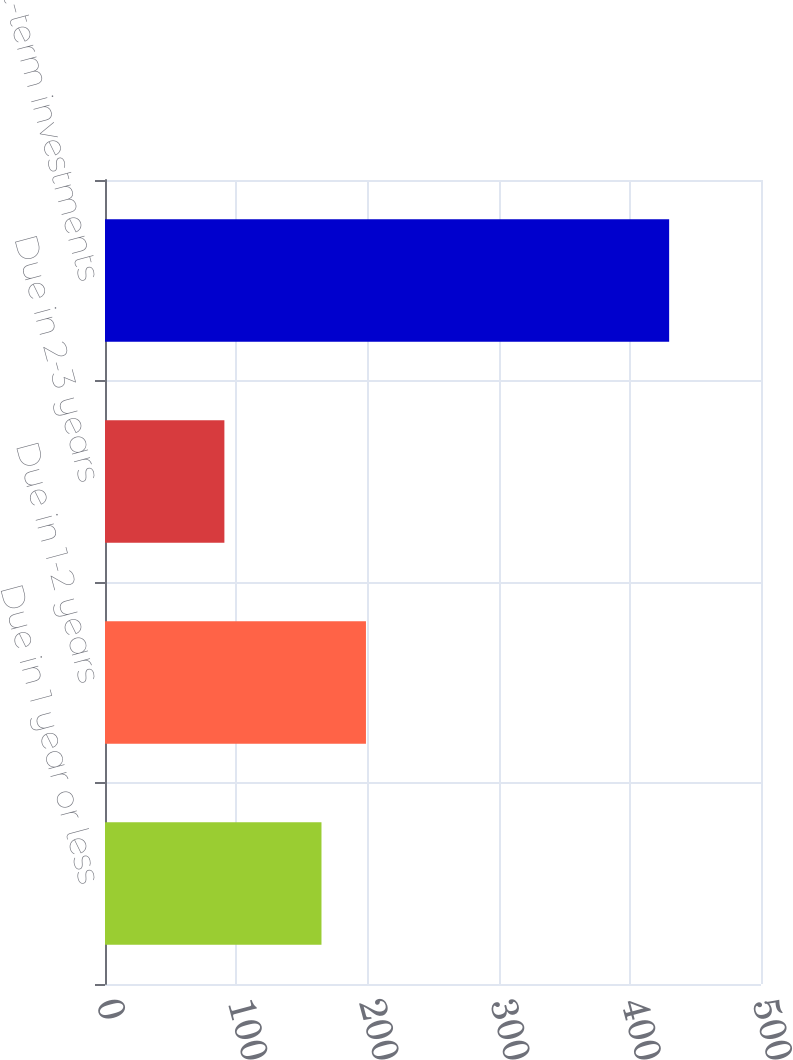<chart> <loc_0><loc_0><loc_500><loc_500><bar_chart><fcel>Due in 1 year or less<fcel>Due in 1-2 years<fcel>Due in 2-3 years<fcel>Short-term investments<nl><fcel>165<fcel>198.9<fcel>91<fcel>430<nl></chart> 